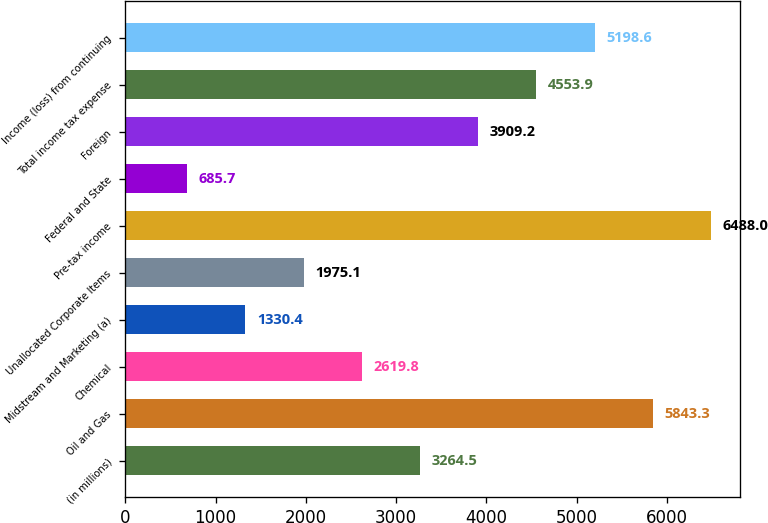Convert chart. <chart><loc_0><loc_0><loc_500><loc_500><bar_chart><fcel>(in millions)<fcel>Oil and Gas<fcel>Chemical<fcel>Midstream and Marketing (a)<fcel>Unallocated Corporate Items<fcel>Pre-tax income<fcel>Federal and State<fcel>Foreign<fcel>Total income tax expense<fcel>Income (loss) from continuing<nl><fcel>3264.5<fcel>5843.3<fcel>2619.8<fcel>1330.4<fcel>1975.1<fcel>6488<fcel>685.7<fcel>3909.2<fcel>4553.9<fcel>5198.6<nl></chart> 